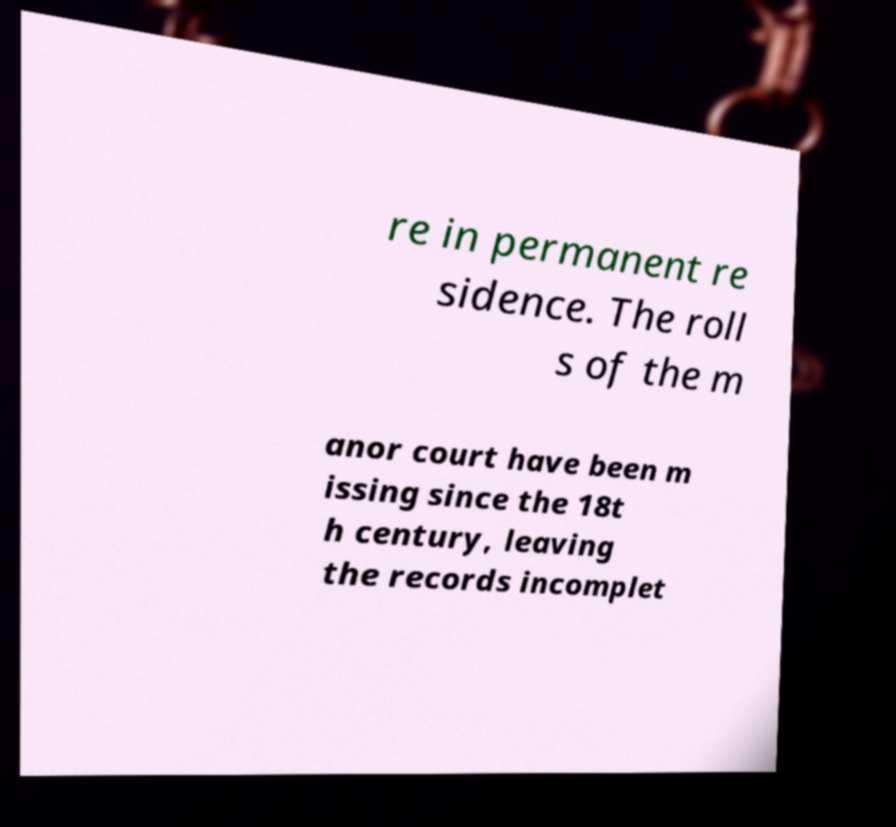Could you extract and type out the text from this image? re in permanent re sidence. The roll s of the m anor court have been m issing since the 18t h century, leaving the records incomplet 